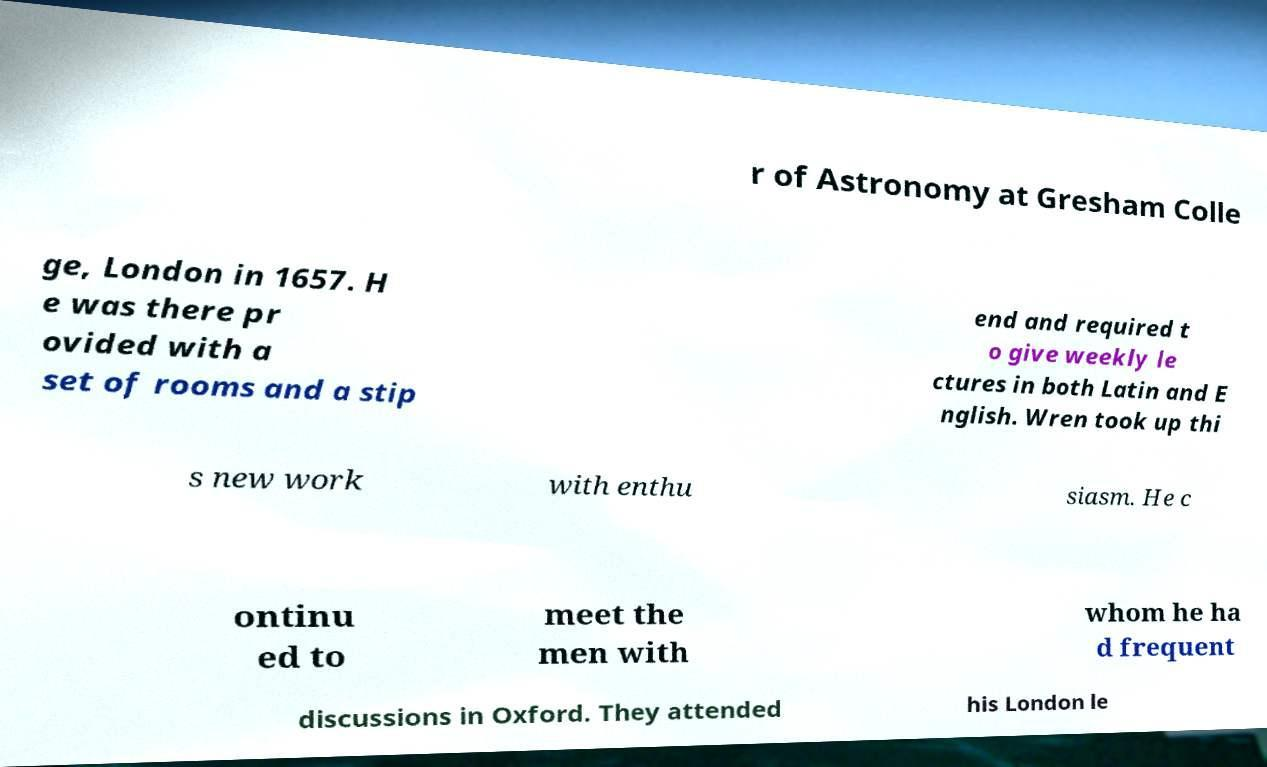Could you extract and type out the text from this image? r of Astronomy at Gresham Colle ge, London in 1657. H e was there pr ovided with a set of rooms and a stip end and required t o give weekly le ctures in both Latin and E nglish. Wren took up thi s new work with enthu siasm. He c ontinu ed to meet the men with whom he ha d frequent discussions in Oxford. They attended his London le 